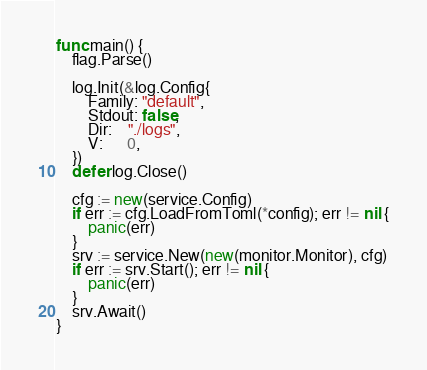<code> <loc_0><loc_0><loc_500><loc_500><_Go_>func main() {
	flag.Parse()

	log.Init(&log.Config{
		Family: "default",
		Stdout: false,
		Dir:    "./logs",
		V:      0,
	})
	defer log.Close()

	cfg := new(service.Config)
	if err := cfg.LoadFromToml(*config); err != nil {
		panic(err)
	}
	srv := service.New(new(monitor.Monitor), cfg)
	if err := srv.Start(); err != nil {
		panic(err)
	}
	srv.Await()
}
</code> 